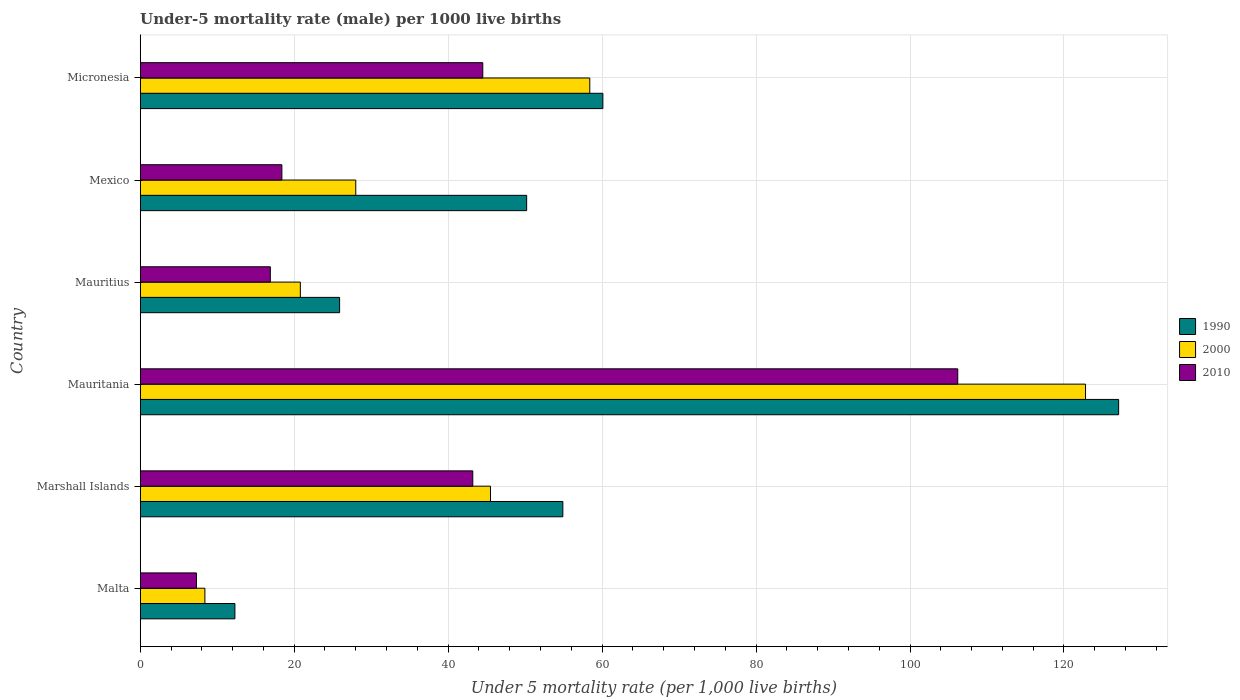How many groups of bars are there?
Your response must be concise. 6. Are the number of bars per tick equal to the number of legend labels?
Give a very brief answer. Yes. Are the number of bars on each tick of the Y-axis equal?
Give a very brief answer. Yes. What is the label of the 4th group of bars from the top?
Make the answer very short. Mauritania. In how many cases, is the number of bars for a given country not equal to the number of legend labels?
Offer a very short reply. 0. What is the under-five mortality rate in 2010 in Malta?
Keep it short and to the point. 7.3. Across all countries, what is the maximum under-five mortality rate in 2000?
Give a very brief answer. 122.8. In which country was the under-five mortality rate in 2000 maximum?
Give a very brief answer. Mauritania. In which country was the under-five mortality rate in 2010 minimum?
Provide a short and direct response. Malta. What is the total under-five mortality rate in 2000 in the graph?
Keep it short and to the point. 283.9. What is the difference between the under-five mortality rate in 2010 in Malta and that in Mauritius?
Offer a very short reply. -9.6. What is the difference between the under-five mortality rate in 2000 in Mauritius and the under-five mortality rate in 2010 in Mexico?
Give a very brief answer. 2.4. What is the average under-five mortality rate in 2000 per country?
Your response must be concise. 47.32. What is the difference between the under-five mortality rate in 2000 and under-five mortality rate in 2010 in Mauritius?
Ensure brevity in your answer.  3.9. What is the ratio of the under-five mortality rate in 2000 in Mauritania to that in Mauritius?
Give a very brief answer. 5.9. Is the difference between the under-five mortality rate in 2000 in Marshall Islands and Mauritius greater than the difference between the under-five mortality rate in 2010 in Marshall Islands and Mauritius?
Your answer should be very brief. No. What is the difference between the highest and the second highest under-five mortality rate in 2010?
Give a very brief answer. 61.7. What is the difference between the highest and the lowest under-five mortality rate in 1990?
Your answer should be compact. 114.8. What does the 3rd bar from the top in Micronesia represents?
Your answer should be very brief. 1990. How many bars are there?
Offer a very short reply. 18. Are all the bars in the graph horizontal?
Ensure brevity in your answer.  Yes. What is the difference between two consecutive major ticks on the X-axis?
Give a very brief answer. 20. Are the values on the major ticks of X-axis written in scientific E-notation?
Give a very brief answer. No. Does the graph contain grids?
Provide a succinct answer. Yes. How are the legend labels stacked?
Your response must be concise. Vertical. What is the title of the graph?
Provide a short and direct response. Under-5 mortality rate (male) per 1000 live births. Does "1997" appear as one of the legend labels in the graph?
Make the answer very short. No. What is the label or title of the X-axis?
Offer a terse response. Under 5 mortality rate (per 1,0 live births). What is the Under 5 mortality rate (per 1,000 live births) of 1990 in Marshall Islands?
Provide a succinct answer. 54.9. What is the Under 5 mortality rate (per 1,000 live births) of 2000 in Marshall Islands?
Offer a very short reply. 45.5. What is the Under 5 mortality rate (per 1,000 live births) of 2010 in Marshall Islands?
Keep it short and to the point. 43.2. What is the Under 5 mortality rate (per 1,000 live births) of 1990 in Mauritania?
Make the answer very short. 127.1. What is the Under 5 mortality rate (per 1,000 live births) in 2000 in Mauritania?
Ensure brevity in your answer.  122.8. What is the Under 5 mortality rate (per 1,000 live births) of 2010 in Mauritania?
Your response must be concise. 106.2. What is the Under 5 mortality rate (per 1,000 live births) of 1990 in Mauritius?
Provide a succinct answer. 25.9. What is the Under 5 mortality rate (per 1,000 live births) in 2000 in Mauritius?
Provide a succinct answer. 20.8. What is the Under 5 mortality rate (per 1,000 live births) of 1990 in Mexico?
Your answer should be compact. 50.2. What is the Under 5 mortality rate (per 1,000 live births) of 2010 in Mexico?
Your answer should be compact. 18.4. What is the Under 5 mortality rate (per 1,000 live births) of 1990 in Micronesia?
Make the answer very short. 60.1. What is the Under 5 mortality rate (per 1,000 live births) of 2000 in Micronesia?
Offer a very short reply. 58.4. What is the Under 5 mortality rate (per 1,000 live births) in 2010 in Micronesia?
Make the answer very short. 44.5. Across all countries, what is the maximum Under 5 mortality rate (per 1,000 live births) in 1990?
Keep it short and to the point. 127.1. Across all countries, what is the maximum Under 5 mortality rate (per 1,000 live births) of 2000?
Offer a terse response. 122.8. Across all countries, what is the maximum Under 5 mortality rate (per 1,000 live births) of 2010?
Make the answer very short. 106.2. Across all countries, what is the minimum Under 5 mortality rate (per 1,000 live births) in 2010?
Your response must be concise. 7.3. What is the total Under 5 mortality rate (per 1,000 live births) of 1990 in the graph?
Keep it short and to the point. 330.5. What is the total Under 5 mortality rate (per 1,000 live births) of 2000 in the graph?
Provide a succinct answer. 283.9. What is the total Under 5 mortality rate (per 1,000 live births) in 2010 in the graph?
Ensure brevity in your answer.  236.5. What is the difference between the Under 5 mortality rate (per 1,000 live births) in 1990 in Malta and that in Marshall Islands?
Ensure brevity in your answer.  -42.6. What is the difference between the Under 5 mortality rate (per 1,000 live births) of 2000 in Malta and that in Marshall Islands?
Ensure brevity in your answer.  -37.1. What is the difference between the Under 5 mortality rate (per 1,000 live births) in 2010 in Malta and that in Marshall Islands?
Make the answer very short. -35.9. What is the difference between the Under 5 mortality rate (per 1,000 live births) of 1990 in Malta and that in Mauritania?
Your answer should be very brief. -114.8. What is the difference between the Under 5 mortality rate (per 1,000 live births) of 2000 in Malta and that in Mauritania?
Offer a terse response. -114.4. What is the difference between the Under 5 mortality rate (per 1,000 live births) in 2010 in Malta and that in Mauritania?
Provide a short and direct response. -98.9. What is the difference between the Under 5 mortality rate (per 1,000 live births) in 1990 in Malta and that in Mauritius?
Offer a very short reply. -13.6. What is the difference between the Under 5 mortality rate (per 1,000 live births) in 2000 in Malta and that in Mauritius?
Give a very brief answer. -12.4. What is the difference between the Under 5 mortality rate (per 1,000 live births) in 2010 in Malta and that in Mauritius?
Your answer should be very brief. -9.6. What is the difference between the Under 5 mortality rate (per 1,000 live births) of 1990 in Malta and that in Mexico?
Ensure brevity in your answer.  -37.9. What is the difference between the Under 5 mortality rate (per 1,000 live births) of 2000 in Malta and that in Mexico?
Your answer should be compact. -19.6. What is the difference between the Under 5 mortality rate (per 1,000 live births) of 1990 in Malta and that in Micronesia?
Your answer should be compact. -47.8. What is the difference between the Under 5 mortality rate (per 1,000 live births) in 2010 in Malta and that in Micronesia?
Ensure brevity in your answer.  -37.2. What is the difference between the Under 5 mortality rate (per 1,000 live births) of 1990 in Marshall Islands and that in Mauritania?
Give a very brief answer. -72.2. What is the difference between the Under 5 mortality rate (per 1,000 live births) in 2000 in Marshall Islands and that in Mauritania?
Your answer should be compact. -77.3. What is the difference between the Under 5 mortality rate (per 1,000 live births) of 2010 in Marshall Islands and that in Mauritania?
Offer a very short reply. -63. What is the difference between the Under 5 mortality rate (per 1,000 live births) of 1990 in Marshall Islands and that in Mauritius?
Your response must be concise. 29. What is the difference between the Under 5 mortality rate (per 1,000 live births) of 2000 in Marshall Islands and that in Mauritius?
Provide a short and direct response. 24.7. What is the difference between the Under 5 mortality rate (per 1,000 live births) in 2010 in Marshall Islands and that in Mauritius?
Make the answer very short. 26.3. What is the difference between the Under 5 mortality rate (per 1,000 live births) in 2010 in Marshall Islands and that in Mexico?
Give a very brief answer. 24.8. What is the difference between the Under 5 mortality rate (per 1,000 live births) of 2000 in Marshall Islands and that in Micronesia?
Offer a terse response. -12.9. What is the difference between the Under 5 mortality rate (per 1,000 live births) in 2010 in Marshall Islands and that in Micronesia?
Your answer should be very brief. -1.3. What is the difference between the Under 5 mortality rate (per 1,000 live births) in 1990 in Mauritania and that in Mauritius?
Provide a succinct answer. 101.2. What is the difference between the Under 5 mortality rate (per 1,000 live births) in 2000 in Mauritania and that in Mauritius?
Your answer should be compact. 102. What is the difference between the Under 5 mortality rate (per 1,000 live births) in 2010 in Mauritania and that in Mauritius?
Your answer should be very brief. 89.3. What is the difference between the Under 5 mortality rate (per 1,000 live births) of 1990 in Mauritania and that in Mexico?
Provide a succinct answer. 76.9. What is the difference between the Under 5 mortality rate (per 1,000 live births) in 2000 in Mauritania and that in Mexico?
Your answer should be compact. 94.8. What is the difference between the Under 5 mortality rate (per 1,000 live births) of 2010 in Mauritania and that in Mexico?
Offer a terse response. 87.8. What is the difference between the Under 5 mortality rate (per 1,000 live births) of 1990 in Mauritania and that in Micronesia?
Give a very brief answer. 67. What is the difference between the Under 5 mortality rate (per 1,000 live births) of 2000 in Mauritania and that in Micronesia?
Provide a succinct answer. 64.4. What is the difference between the Under 5 mortality rate (per 1,000 live births) in 2010 in Mauritania and that in Micronesia?
Your answer should be very brief. 61.7. What is the difference between the Under 5 mortality rate (per 1,000 live births) of 1990 in Mauritius and that in Mexico?
Offer a terse response. -24.3. What is the difference between the Under 5 mortality rate (per 1,000 live births) of 2000 in Mauritius and that in Mexico?
Offer a very short reply. -7.2. What is the difference between the Under 5 mortality rate (per 1,000 live births) in 1990 in Mauritius and that in Micronesia?
Provide a succinct answer. -34.2. What is the difference between the Under 5 mortality rate (per 1,000 live births) of 2000 in Mauritius and that in Micronesia?
Ensure brevity in your answer.  -37.6. What is the difference between the Under 5 mortality rate (per 1,000 live births) in 2010 in Mauritius and that in Micronesia?
Your answer should be compact. -27.6. What is the difference between the Under 5 mortality rate (per 1,000 live births) in 1990 in Mexico and that in Micronesia?
Keep it short and to the point. -9.9. What is the difference between the Under 5 mortality rate (per 1,000 live births) of 2000 in Mexico and that in Micronesia?
Offer a terse response. -30.4. What is the difference between the Under 5 mortality rate (per 1,000 live births) in 2010 in Mexico and that in Micronesia?
Give a very brief answer. -26.1. What is the difference between the Under 5 mortality rate (per 1,000 live births) of 1990 in Malta and the Under 5 mortality rate (per 1,000 live births) of 2000 in Marshall Islands?
Offer a terse response. -33.2. What is the difference between the Under 5 mortality rate (per 1,000 live births) in 1990 in Malta and the Under 5 mortality rate (per 1,000 live births) in 2010 in Marshall Islands?
Ensure brevity in your answer.  -30.9. What is the difference between the Under 5 mortality rate (per 1,000 live births) of 2000 in Malta and the Under 5 mortality rate (per 1,000 live births) of 2010 in Marshall Islands?
Offer a terse response. -34.8. What is the difference between the Under 5 mortality rate (per 1,000 live births) of 1990 in Malta and the Under 5 mortality rate (per 1,000 live births) of 2000 in Mauritania?
Offer a terse response. -110.5. What is the difference between the Under 5 mortality rate (per 1,000 live births) in 1990 in Malta and the Under 5 mortality rate (per 1,000 live births) in 2010 in Mauritania?
Make the answer very short. -93.9. What is the difference between the Under 5 mortality rate (per 1,000 live births) of 2000 in Malta and the Under 5 mortality rate (per 1,000 live births) of 2010 in Mauritania?
Provide a short and direct response. -97.8. What is the difference between the Under 5 mortality rate (per 1,000 live births) of 1990 in Malta and the Under 5 mortality rate (per 1,000 live births) of 2000 in Mauritius?
Give a very brief answer. -8.5. What is the difference between the Under 5 mortality rate (per 1,000 live births) of 1990 in Malta and the Under 5 mortality rate (per 1,000 live births) of 2010 in Mauritius?
Your answer should be very brief. -4.6. What is the difference between the Under 5 mortality rate (per 1,000 live births) of 2000 in Malta and the Under 5 mortality rate (per 1,000 live births) of 2010 in Mauritius?
Your response must be concise. -8.5. What is the difference between the Under 5 mortality rate (per 1,000 live births) of 1990 in Malta and the Under 5 mortality rate (per 1,000 live births) of 2000 in Mexico?
Offer a very short reply. -15.7. What is the difference between the Under 5 mortality rate (per 1,000 live births) of 1990 in Malta and the Under 5 mortality rate (per 1,000 live births) of 2010 in Mexico?
Offer a terse response. -6.1. What is the difference between the Under 5 mortality rate (per 1,000 live births) of 2000 in Malta and the Under 5 mortality rate (per 1,000 live births) of 2010 in Mexico?
Make the answer very short. -10. What is the difference between the Under 5 mortality rate (per 1,000 live births) of 1990 in Malta and the Under 5 mortality rate (per 1,000 live births) of 2000 in Micronesia?
Your answer should be compact. -46.1. What is the difference between the Under 5 mortality rate (per 1,000 live births) of 1990 in Malta and the Under 5 mortality rate (per 1,000 live births) of 2010 in Micronesia?
Provide a short and direct response. -32.2. What is the difference between the Under 5 mortality rate (per 1,000 live births) in 2000 in Malta and the Under 5 mortality rate (per 1,000 live births) in 2010 in Micronesia?
Offer a terse response. -36.1. What is the difference between the Under 5 mortality rate (per 1,000 live births) in 1990 in Marshall Islands and the Under 5 mortality rate (per 1,000 live births) in 2000 in Mauritania?
Ensure brevity in your answer.  -67.9. What is the difference between the Under 5 mortality rate (per 1,000 live births) of 1990 in Marshall Islands and the Under 5 mortality rate (per 1,000 live births) of 2010 in Mauritania?
Provide a short and direct response. -51.3. What is the difference between the Under 5 mortality rate (per 1,000 live births) of 2000 in Marshall Islands and the Under 5 mortality rate (per 1,000 live births) of 2010 in Mauritania?
Give a very brief answer. -60.7. What is the difference between the Under 5 mortality rate (per 1,000 live births) in 1990 in Marshall Islands and the Under 5 mortality rate (per 1,000 live births) in 2000 in Mauritius?
Provide a succinct answer. 34.1. What is the difference between the Under 5 mortality rate (per 1,000 live births) in 2000 in Marshall Islands and the Under 5 mortality rate (per 1,000 live births) in 2010 in Mauritius?
Offer a terse response. 28.6. What is the difference between the Under 5 mortality rate (per 1,000 live births) in 1990 in Marshall Islands and the Under 5 mortality rate (per 1,000 live births) in 2000 in Mexico?
Keep it short and to the point. 26.9. What is the difference between the Under 5 mortality rate (per 1,000 live births) in 1990 in Marshall Islands and the Under 5 mortality rate (per 1,000 live births) in 2010 in Mexico?
Your answer should be compact. 36.5. What is the difference between the Under 5 mortality rate (per 1,000 live births) in 2000 in Marshall Islands and the Under 5 mortality rate (per 1,000 live births) in 2010 in Mexico?
Give a very brief answer. 27.1. What is the difference between the Under 5 mortality rate (per 1,000 live births) of 2000 in Marshall Islands and the Under 5 mortality rate (per 1,000 live births) of 2010 in Micronesia?
Provide a short and direct response. 1. What is the difference between the Under 5 mortality rate (per 1,000 live births) in 1990 in Mauritania and the Under 5 mortality rate (per 1,000 live births) in 2000 in Mauritius?
Give a very brief answer. 106.3. What is the difference between the Under 5 mortality rate (per 1,000 live births) of 1990 in Mauritania and the Under 5 mortality rate (per 1,000 live births) of 2010 in Mauritius?
Provide a short and direct response. 110.2. What is the difference between the Under 5 mortality rate (per 1,000 live births) of 2000 in Mauritania and the Under 5 mortality rate (per 1,000 live births) of 2010 in Mauritius?
Keep it short and to the point. 105.9. What is the difference between the Under 5 mortality rate (per 1,000 live births) in 1990 in Mauritania and the Under 5 mortality rate (per 1,000 live births) in 2000 in Mexico?
Your answer should be compact. 99.1. What is the difference between the Under 5 mortality rate (per 1,000 live births) of 1990 in Mauritania and the Under 5 mortality rate (per 1,000 live births) of 2010 in Mexico?
Give a very brief answer. 108.7. What is the difference between the Under 5 mortality rate (per 1,000 live births) of 2000 in Mauritania and the Under 5 mortality rate (per 1,000 live births) of 2010 in Mexico?
Offer a very short reply. 104.4. What is the difference between the Under 5 mortality rate (per 1,000 live births) in 1990 in Mauritania and the Under 5 mortality rate (per 1,000 live births) in 2000 in Micronesia?
Give a very brief answer. 68.7. What is the difference between the Under 5 mortality rate (per 1,000 live births) in 1990 in Mauritania and the Under 5 mortality rate (per 1,000 live births) in 2010 in Micronesia?
Give a very brief answer. 82.6. What is the difference between the Under 5 mortality rate (per 1,000 live births) of 2000 in Mauritania and the Under 5 mortality rate (per 1,000 live births) of 2010 in Micronesia?
Ensure brevity in your answer.  78.3. What is the difference between the Under 5 mortality rate (per 1,000 live births) in 1990 in Mauritius and the Under 5 mortality rate (per 1,000 live births) in 2010 in Mexico?
Provide a short and direct response. 7.5. What is the difference between the Under 5 mortality rate (per 1,000 live births) of 2000 in Mauritius and the Under 5 mortality rate (per 1,000 live births) of 2010 in Mexico?
Your answer should be very brief. 2.4. What is the difference between the Under 5 mortality rate (per 1,000 live births) of 1990 in Mauritius and the Under 5 mortality rate (per 1,000 live births) of 2000 in Micronesia?
Provide a succinct answer. -32.5. What is the difference between the Under 5 mortality rate (per 1,000 live births) in 1990 in Mauritius and the Under 5 mortality rate (per 1,000 live births) in 2010 in Micronesia?
Provide a short and direct response. -18.6. What is the difference between the Under 5 mortality rate (per 1,000 live births) of 2000 in Mauritius and the Under 5 mortality rate (per 1,000 live births) of 2010 in Micronesia?
Your answer should be compact. -23.7. What is the difference between the Under 5 mortality rate (per 1,000 live births) in 2000 in Mexico and the Under 5 mortality rate (per 1,000 live births) in 2010 in Micronesia?
Provide a short and direct response. -16.5. What is the average Under 5 mortality rate (per 1,000 live births) of 1990 per country?
Your answer should be very brief. 55.08. What is the average Under 5 mortality rate (per 1,000 live births) in 2000 per country?
Give a very brief answer. 47.32. What is the average Under 5 mortality rate (per 1,000 live births) in 2010 per country?
Offer a terse response. 39.42. What is the difference between the Under 5 mortality rate (per 1,000 live births) of 1990 and Under 5 mortality rate (per 1,000 live births) of 2000 in Malta?
Your answer should be very brief. 3.9. What is the difference between the Under 5 mortality rate (per 1,000 live births) in 1990 and Under 5 mortality rate (per 1,000 live births) in 2010 in Malta?
Ensure brevity in your answer.  5. What is the difference between the Under 5 mortality rate (per 1,000 live births) of 2000 and Under 5 mortality rate (per 1,000 live births) of 2010 in Malta?
Offer a very short reply. 1.1. What is the difference between the Under 5 mortality rate (per 1,000 live births) of 1990 and Under 5 mortality rate (per 1,000 live births) of 2000 in Marshall Islands?
Your response must be concise. 9.4. What is the difference between the Under 5 mortality rate (per 1,000 live births) of 1990 and Under 5 mortality rate (per 1,000 live births) of 2010 in Marshall Islands?
Offer a terse response. 11.7. What is the difference between the Under 5 mortality rate (per 1,000 live births) of 1990 and Under 5 mortality rate (per 1,000 live births) of 2010 in Mauritania?
Offer a terse response. 20.9. What is the difference between the Under 5 mortality rate (per 1,000 live births) of 1990 and Under 5 mortality rate (per 1,000 live births) of 2000 in Mauritius?
Provide a short and direct response. 5.1. What is the difference between the Under 5 mortality rate (per 1,000 live births) in 1990 and Under 5 mortality rate (per 1,000 live births) in 2010 in Mauritius?
Provide a short and direct response. 9. What is the difference between the Under 5 mortality rate (per 1,000 live births) of 1990 and Under 5 mortality rate (per 1,000 live births) of 2000 in Mexico?
Provide a succinct answer. 22.2. What is the difference between the Under 5 mortality rate (per 1,000 live births) in 1990 and Under 5 mortality rate (per 1,000 live births) in 2010 in Mexico?
Offer a very short reply. 31.8. What is the difference between the Under 5 mortality rate (per 1,000 live births) of 2000 and Under 5 mortality rate (per 1,000 live births) of 2010 in Mexico?
Give a very brief answer. 9.6. What is the difference between the Under 5 mortality rate (per 1,000 live births) of 1990 and Under 5 mortality rate (per 1,000 live births) of 2000 in Micronesia?
Provide a succinct answer. 1.7. What is the ratio of the Under 5 mortality rate (per 1,000 live births) of 1990 in Malta to that in Marshall Islands?
Your answer should be very brief. 0.22. What is the ratio of the Under 5 mortality rate (per 1,000 live births) of 2000 in Malta to that in Marshall Islands?
Offer a very short reply. 0.18. What is the ratio of the Under 5 mortality rate (per 1,000 live births) of 2010 in Malta to that in Marshall Islands?
Offer a very short reply. 0.17. What is the ratio of the Under 5 mortality rate (per 1,000 live births) in 1990 in Malta to that in Mauritania?
Make the answer very short. 0.1. What is the ratio of the Under 5 mortality rate (per 1,000 live births) in 2000 in Malta to that in Mauritania?
Offer a terse response. 0.07. What is the ratio of the Under 5 mortality rate (per 1,000 live births) in 2010 in Malta to that in Mauritania?
Offer a very short reply. 0.07. What is the ratio of the Under 5 mortality rate (per 1,000 live births) in 1990 in Malta to that in Mauritius?
Your answer should be very brief. 0.47. What is the ratio of the Under 5 mortality rate (per 1,000 live births) in 2000 in Malta to that in Mauritius?
Keep it short and to the point. 0.4. What is the ratio of the Under 5 mortality rate (per 1,000 live births) in 2010 in Malta to that in Mauritius?
Offer a terse response. 0.43. What is the ratio of the Under 5 mortality rate (per 1,000 live births) of 1990 in Malta to that in Mexico?
Make the answer very short. 0.24. What is the ratio of the Under 5 mortality rate (per 1,000 live births) of 2010 in Malta to that in Mexico?
Ensure brevity in your answer.  0.4. What is the ratio of the Under 5 mortality rate (per 1,000 live births) of 1990 in Malta to that in Micronesia?
Your response must be concise. 0.2. What is the ratio of the Under 5 mortality rate (per 1,000 live births) in 2000 in Malta to that in Micronesia?
Provide a short and direct response. 0.14. What is the ratio of the Under 5 mortality rate (per 1,000 live births) in 2010 in Malta to that in Micronesia?
Your answer should be compact. 0.16. What is the ratio of the Under 5 mortality rate (per 1,000 live births) in 1990 in Marshall Islands to that in Mauritania?
Provide a short and direct response. 0.43. What is the ratio of the Under 5 mortality rate (per 1,000 live births) of 2000 in Marshall Islands to that in Mauritania?
Your answer should be very brief. 0.37. What is the ratio of the Under 5 mortality rate (per 1,000 live births) in 2010 in Marshall Islands to that in Mauritania?
Provide a succinct answer. 0.41. What is the ratio of the Under 5 mortality rate (per 1,000 live births) of 1990 in Marshall Islands to that in Mauritius?
Provide a succinct answer. 2.12. What is the ratio of the Under 5 mortality rate (per 1,000 live births) in 2000 in Marshall Islands to that in Mauritius?
Offer a terse response. 2.19. What is the ratio of the Under 5 mortality rate (per 1,000 live births) of 2010 in Marshall Islands to that in Mauritius?
Give a very brief answer. 2.56. What is the ratio of the Under 5 mortality rate (per 1,000 live births) in 1990 in Marshall Islands to that in Mexico?
Offer a very short reply. 1.09. What is the ratio of the Under 5 mortality rate (per 1,000 live births) of 2000 in Marshall Islands to that in Mexico?
Keep it short and to the point. 1.62. What is the ratio of the Under 5 mortality rate (per 1,000 live births) in 2010 in Marshall Islands to that in Mexico?
Your answer should be compact. 2.35. What is the ratio of the Under 5 mortality rate (per 1,000 live births) of 1990 in Marshall Islands to that in Micronesia?
Make the answer very short. 0.91. What is the ratio of the Under 5 mortality rate (per 1,000 live births) of 2000 in Marshall Islands to that in Micronesia?
Make the answer very short. 0.78. What is the ratio of the Under 5 mortality rate (per 1,000 live births) in 2010 in Marshall Islands to that in Micronesia?
Keep it short and to the point. 0.97. What is the ratio of the Under 5 mortality rate (per 1,000 live births) of 1990 in Mauritania to that in Mauritius?
Provide a short and direct response. 4.91. What is the ratio of the Under 5 mortality rate (per 1,000 live births) in 2000 in Mauritania to that in Mauritius?
Make the answer very short. 5.9. What is the ratio of the Under 5 mortality rate (per 1,000 live births) in 2010 in Mauritania to that in Mauritius?
Your response must be concise. 6.28. What is the ratio of the Under 5 mortality rate (per 1,000 live births) of 1990 in Mauritania to that in Mexico?
Give a very brief answer. 2.53. What is the ratio of the Under 5 mortality rate (per 1,000 live births) of 2000 in Mauritania to that in Mexico?
Give a very brief answer. 4.39. What is the ratio of the Under 5 mortality rate (per 1,000 live births) in 2010 in Mauritania to that in Mexico?
Make the answer very short. 5.77. What is the ratio of the Under 5 mortality rate (per 1,000 live births) in 1990 in Mauritania to that in Micronesia?
Offer a very short reply. 2.11. What is the ratio of the Under 5 mortality rate (per 1,000 live births) of 2000 in Mauritania to that in Micronesia?
Make the answer very short. 2.1. What is the ratio of the Under 5 mortality rate (per 1,000 live births) of 2010 in Mauritania to that in Micronesia?
Your answer should be compact. 2.39. What is the ratio of the Under 5 mortality rate (per 1,000 live births) in 1990 in Mauritius to that in Mexico?
Keep it short and to the point. 0.52. What is the ratio of the Under 5 mortality rate (per 1,000 live births) of 2000 in Mauritius to that in Mexico?
Your answer should be very brief. 0.74. What is the ratio of the Under 5 mortality rate (per 1,000 live births) in 2010 in Mauritius to that in Mexico?
Make the answer very short. 0.92. What is the ratio of the Under 5 mortality rate (per 1,000 live births) of 1990 in Mauritius to that in Micronesia?
Offer a very short reply. 0.43. What is the ratio of the Under 5 mortality rate (per 1,000 live births) in 2000 in Mauritius to that in Micronesia?
Your answer should be compact. 0.36. What is the ratio of the Under 5 mortality rate (per 1,000 live births) in 2010 in Mauritius to that in Micronesia?
Keep it short and to the point. 0.38. What is the ratio of the Under 5 mortality rate (per 1,000 live births) in 1990 in Mexico to that in Micronesia?
Your answer should be compact. 0.84. What is the ratio of the Under 5 mortality rate (per 1,000 live births) of 2000 in Mexico to that in Micronesia?
Make the answer very short. 0.48. What is the ratio of the Under 5 mortality rate (per 1,000 live births) of 2010 in Mexico to that in Micronesia?
Offer a very short reply. 0.41. What is the difference between the highest and the second highest Under 5 mortality rate (per 1,000 live births) in 1990?
Provide a short and direct response. 67. What is the difference between the highest and the second highest Under 5 mortality rate (per 1,000 live births) of 2000?
Provide a short and direct response. 64.4. What is the difference between the highest and the second highest Under 5 mortality rate (per 1,000 live births) in 2010?
Make the answer very short. 61.7. What is the difference between the highest and the lowest Under 5 mortality rate (per 1,000 live births) in 1990?
Provide a succinct answer. 114.8. What is the difference between the highest and the lowest Under 5 mortality rate (per 1,000 live births) in 2000?
Give a very brief answer. 114.4. What is the difference between the highest and the lowest Under 5 mortality rate (per 1,000 live births) in 2010?
Your response must be concise. 98.9. 